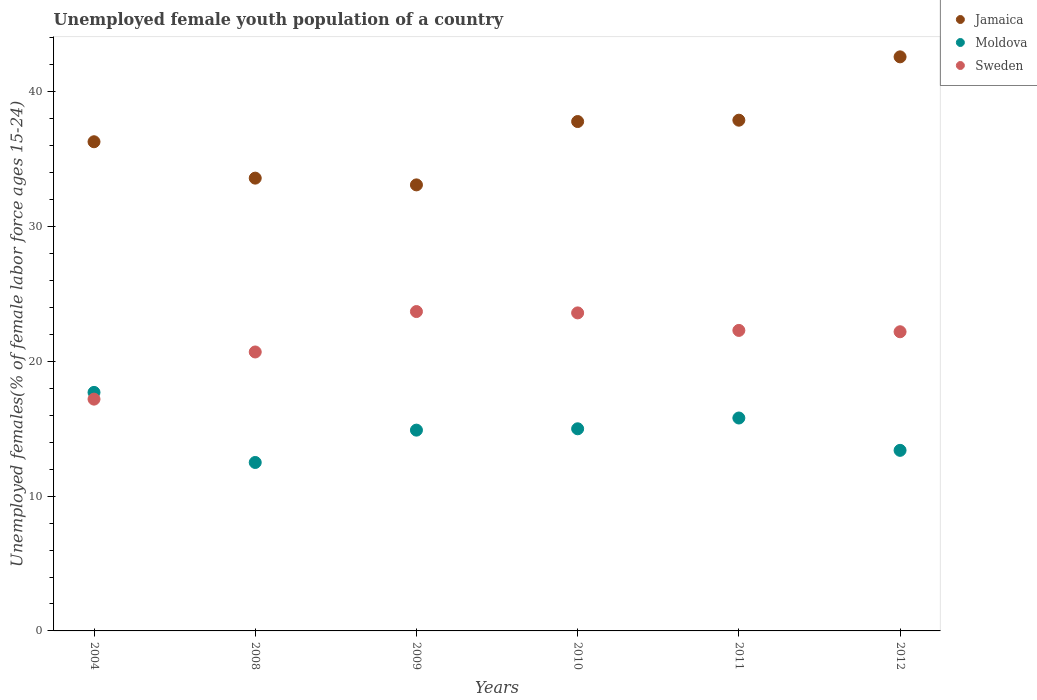How many different coloured dotlines are there?
Give a very brief answer. 3. What is the percentage of unemployed female youth population in Sweden in 2009?
Provide a short and direct response. 23.7. Across all years, what is the maximum percentage of unemployed female youth population in Jamaica?
Offer a very short reply. 42.6. In which year was the percentage of unemployed female youth population in Moldova minimum?
Provide a succinct answer. 2008. What is the total percentage of unemployed female youth population in Sweden in the graph?
Your answer should be compact. 129.7. What is the difference between the percentage of unemployed female youth population in Moldova in 2010 and the percentage of unemployed female youth population in Sweden in 2009?
Make the answer very short. -8.7. What is the average percentage of unemployed female youth population in Moldova per year?
Provide a succinct answer. 14.88. In the year 2010, what is the difference between the percentage of unemployed female youth population in Sweden and percentage of unemployed female youth population in Moldova?
Provide a short and direct response. 8.6. In how many years, is the percentage of unemployed female youth population in Jamaica greater than 20 %?
Make the answer very short. 6. What is the ratio of the percentage of unemployed female youth population in Jamaica in 2009 to that in 2010?
Make the answer very short. 0.88. Is the difference between the percentage of unemployed female youth population in Sweden in 2004 and 2008 greater than the difference between the percentage of unemployed female youth population in Moldova in 2004 and 2008?
Provide a succinct answer. No. What is the difference between the highest and the second highest percentage of unemployed female youth population in Moldova?
Provide a short and direct response. 1.9. What is the difference between the highest and the lowest percentage of unemployed female youth population in Moldova?
Offer a very short reply. 5.2. Is the sum of the percentage of unemployed female youth population in Moldova in 2010 and 2012 greater than the maximum percentage of unemployed female youth population in Sweden across all years?
Ensure brevity in your answer.  Yes. Does the percentage of unemployed female youth population in Moldova monotonically increase over the years?
Your response must be concise. No. Is the percentage of unemployed female youth population in Moldova strictly less than the percentage of unemployed female youth population in Sweden over the years?
Your answer should be compact. No. How many years are there in the graph?
Offer a terse response. 6. Does the graph contain any zero values?
Make the answer very short. No. Where does the legend appear in the graph?
Your response must be concise. Top right. What is the title of the graph?
Your response must be concise. Unemployed female youth population of a country. Does "Rwanda" appear as one of the legend labels in the graph?
Provide a succinct answer. No. What is the label or title of the X-axis?
Make the answer very short. Years. What is the label or title of the Y-axis?
Offer a terse response. Unemployed females(% of female labor force ages 15-24). What is the Unemployed females(% of female labor force ages 15-24) of Jamaica in 2004?
Offer a very short reply. 36.3. What is the Unemployed females(% of female labor force ages 15-24) of Moldova in 2004?
Offer a terse response. 17.7. What is the Unemployed females(% of female labor force ages 15-24) of Sweden in 2004?
Offer a terse response. 17.2. What is the Unemployed females(% of female labor force ages 15-24) in Jamaica in 2008?
Offer a terse response. 33.6. What is the Unemployed females(% of female labor force ages 15-24) of Sweden in 2008?
Your answer should be very brief. 20.7. What is the Unemployed females(% of female labor force ages 15-24) of Jamaica in 2009?
Your answer should be compact. 33.1. What is the Unemployed females(% of female labor force ages 15-24) in Moldova in 2009?
Your response must be concise. 14.9. What is the Unemployed females(% of female labor force ages 15-24) in Sweden in 2009?
Offer a terse response. 23.7. What is the Unemployed females(% of female labor force ages 15-24) of Jamaica in 2010?
Ensure brevity in your answer.  37.8. What is the Unemployed females(% of female labor force ages 15-24) in Sweden in 2010?
Keep it short and to the point. 23.6. What is the Unemployed females(% of female labor force ages 15-24) of Jamaica in 2011?
Keep it short and to the point. 37.9. What is the Unemployed females(% of female labor force ages 15-24) of Moldova in 2011?
Give a very brief answer. 15.8. What is the Unemployed females(% of female labor force ages 15-24) of Sweden in 2011?
Provide a succinct answer. 22.3. What is the Unemployed females(% of female labor force ages 15-24) in Jamaica in 2012?
Provide a succinct answer. 42.6. What is the Unemployed females(% of female labor force ages 15-24) of Moldova in 2012?
Make the answer very short. 13.4. What is the Unemployed females(% of female labor force ages 15-24) in Sweden in 2012?
Offer a very short reply. 22.2. Across all years, what is the maximum Unemployed females(% of female labor force ages 15-24) of Jamaica?
Provide a short and direct response. 42.6. Across all years, what is the maximum Unemployed females(% of female labor force ages 15-24) in Moldova?
Provide a short and direct response. 17.7. Across all years, what is the maximum Unemployed females(% of female labor force ages 15-24) in Sweden?
Your answer should be compact. 23.7. Across all years, what is the minimum Unemployed females(% of female labor force ages 15-24) in Jamaica?
Provide a short and direct response. 33.1. Across all years, what is the minimum Unemployed females(% of female labor force ages 15-24) in Sweden?
Offer a very short reply. 17.2. What is the total Unemployed females(% of female labor force ages 15-24) in Jamaica in the graph?
Your response must be concise. 221.3. What is the total Unemployed females(% of female labor force ages 15-24) in Moldova in the graph?
Offer a terse response. 89.3. What is the total Unemployed females(% of female labor force ages 15-24) of Sweden in the graph?
Provide a short and direct response. 129.7. What is the difference between the Unemployed females(% of female labor force ages 15-24) in Sweden in 2004 and that in 2008?
Keep it short and to the point. -3.5. What is the difference between the Unemployed females(% of female labor force ages 15-24) in Jamaica in 2004 and that in 2009?
Keep it short and to the point. 3.2. What is the difference between the Unemployed females(% of female labor force ages 15-24) in Sweden in 2004 and that in 2010?
Provide a short and direct response. -6.4. What is the difference between the Unemployed females(% of female labor force ages 15-24) in Moldova in 2004 and that in 2011?
Provide a short and direct response. 1.9. What is the difference between the Unemployed females(% of female labor force ages 15-24) of Moldova in 2004 and that in 2012?
Provide a short and direct response. 4.3. What is the difference between the Unemployed females(% of female labor force ages 15-24) in Sweden in 2004 and that in 2012?
Offer a very short reply. -5. What is the difference between the Unemployed females(% of female labor force ages 15-24) of Moldova in 2008 and that in 2010?
Your answer should be very brief. -2.5. What is the difference between the Unemployed females(% of female labor force ages 15-24) of Jamaica in 2008 and that in 2011?
Your answer should be very brief. -4.3. What is the difference between the Unemployed females(% of female labor force ages 15-24) in Moldova in 2009 and that in 2011?
Make the answer very short. -0.9. What is the difference between the Unemployed females(% of female labor force ages 15-24) of Sweden in 2009 and that in 2011?
Your answer should be compact. 1.4. What is the difference between the Unemployed females(% of female labor force ages 15-24) in Moldova in 2009 and that in 2012?
Give a very brief answer. 1.5. What is the difference between the Unemployed females(% of female labor force ages 15-24) in Moldova in 2010 and that in 2011?
Your answer should be compact. -0.8. What is the difference between the Unemployed females(% of female labor force ages 15-24) of Sweden in 2010 and that in 2011?
Provide a succinct answer. 1.3. What is the difference between the Unemployed females(% of female labor force ages 15-24) in Jamaica in 2010 and that in 2012?
Offer a very short reply. -4.8. What is the difference between the Unemployed females(% of female labor force ages 15-24) in Sweden in 2010 and that in 2012?
Keep it short and to the point. 1.4. What is the difference between the Unemployed females(% of female labor force ages 15-24) in Jamaica in 2004 and the Unemployed females(% of female labor force ages 15-24) in Moldova in 2008?
Ensure brevity in your answer.  23.8. What is the difference between the Unemployed females(% of female labor force ages 15-24) of Jamaica in 2004 and the Unemployed females(% of female labor force ages 15-24) of Sweden in 2008?
Your response must be concise. 15.6. What is the difference between the Unemployed females(% of female labor force ages 15-24) in Jamaica in 2004 and the Unemployed females(% of female labor force ages 15-24) in Moldova in 2009?
Your answer should be compact. 21.4. What is the difference between the Unemployed females(% of female labor force ages 15-24) of Jamaica in 2004 and the Unemployed females(% of female labor force ages 15-24) of Sweden in 2009?
Ensure brevity in your answer.  12.6. What is the difference between the Unemployed females(% of female labor force ages 15-24) of Jamaica in 2004 and the Unemployed females(% of female labor force ages 15-24) of Moldova in 2010?
Your response must be concise. 21.3. What is the difference between the Unemployed females(% of female labor force ages 15-24) in Jamaica in 2004 and the Unemployed females(% of female labor force ages 15-24) in Sweden in 2010?
Give a very brief answer. 12.7. What is the difference between the Unemployed females(% of female labor force ages 15-24) in Moldova in 2004 and the Unemployed females(% of female labor force ages 15-24) in Sweden in 2010?
Your answer should be compact. -5.9. What is the difference between the Unemployed females(% of female labor force ages 15-24) in Jamaica in 2004 and the Unemployed females(% of female labor force ages 15-24) in Moldova in 2011?
Give a very brief answer. 20.5. What is the difference between the Unemployed females(% of female labor force ages 15-24) of Jamaica in 2004 and the Unemployed females(% of female labor force ages 15-24) of Sweden in 2011?
Keep it short and to the point. 14. What is the difference between the Unemployed females(% of female labor force ages 15-24) in Moldova in 2004 and the Unemployed females(% of female labor force ages 15-24) in Sweden in 2011?
Make the answer very short. -4.6. What is the difference between the Unemployed females(% of female labor force ages 15-24) in Jamaica in 2004 and the Unemployed females(% of female labor force ages 15-24) in Moldova in 2012?
Give a very brief answer. 22.9. What is the difference between the Unemployed females(% of female labor force ages 15-24) in Jamaica in 2004 and the Unemployed females(% of female labor force ages 15-24) in Sweden in 2012?
Give a very brief answer. 14.1. What is the difference between the Unemployed females(% of female labor force ages 15-24) of Jamaica in 2008 and the Unemployed females(% of female labor force ages 15-24) of Sweden in 2009?
Make the answer very short. 9.9. What is the difference between the Unemployed females(% of female labor force ages 15-24) of Moldova in 2008 and the Unemployed females(% of female labor force ages 15-24) of Sweden in 2009?
Your answer should be very brief. -11.2. What is the difference between the Unemployed females(% of female labor force ages 15-24) in Jamaica in 2008 and the Unemployed females(% of female labor force ages 15-24) in Moldova in 2010?
Your response must be concise. 18.6. What is the difference between the Unemployed females(% of female labor force ages 15-24) in Jamaica in 2008 and the Unemployed females(% of female labor force ages 15-24) in Sweden in 2010?
Offer a very short reply. 10. What is the difference between the Unemployed females(% of female labor force ages 15-24) in Moldova in 2008 and the Unemployed females(% of female labor force ages 15-24) in Sweden in 2010?
Make the answer very short. -11.1. What is the difference between the Unemployed females(% of female labor force ages 15-24) in Moldova in 2008 and the Unemployed females(% of female labor force ages 15-24) in Sweden in 2011?
Keep it short and to the point. -9.8. What is the difference between the Unemployed females(% of female labor force ages 15-24) in Jamaica in 2008 and the Unemployed females(% of female labor force ages 15-24) in Moldova in 2012?
Your response must be concise. 20.2. What is the difference between the Unemployed females(% of female labor force ages 15-24) of Jamaica in 2009 and the Unemployed females(% of female labor force ages 15-24) of Moldova in 2010?
Keep it short and to the point. 18.1. What is the difference between the Unemployed females(% of female labor force ages 15-24) in Jamaica in 2009 and the Unemployed females(% of female labor force ages 15-24) in Sweden in 2011?
Provide a short and direct response. 10.8. What is the difference between the Unemployed females(% of female labor force ages 15-24) in Moldova in 2009 and the Unemployed females(% of female labor force ages 15-24) in Sweden in 2011?
Provide a succinct answer. -7.4. What is the difference between the Unemployed females(% of female labor force ages 15-24) in Moldova in 2009 and the Unemployed females(% of female labor force ages 15-24) in Sweden in 2012?
Offer a very short reply. -7.3. What is the difference between the Unemployed females(% of female labor force ages 15-24) of Jamaica in 2010 and the Unemployed females(% of female labor force ages 15-24) of Moldova in 2011?
Offer a terse response. 22. What is the difference between the Unemployed females(% of female labor force ages 15-24) of Jamaica in 2010 and the Unemployed females(% of female labor force ages 15-24) of Sweden in 2011?
Provide a short and direct response. 15.5. What is the difference between the Unemployed females(% of female labor force ages 15-24) in Jamaica in 2010 and the Unemployed females(% of female labor force ages 15-24) in Moldova in 2012?
Keep it short and to the point. 24.4. What is the difference between the Unemployed females(% of female labor force ages 15-24) of Jamaica in 2010 and the Unemployed females(% of female labor force ages 15-24) of Sweden in 2012?
Your answer should be compact. 15.6. What is the difference between the Unemployed females(% of female labor force ages 15-24) of Jamaica in 2011 and the Unemployed females(% of female labor force ages 15-24) of Moldova in 2012?
Offer a terse response. 24.5. What is the difference between the Unemployed females(% of female labor force ages 15-24) in Jamaica in 2011 and the Unemployed females(% of female labor force ages 15-24) in Sweden in 2012?
Provide a succinct answer. 15.7. What is the average Unemployed females(% of female labor force ages 15-24) of Jamaica per year?
Offer a very short reply. 36.88. What is the average Unemployed females(% of female labor force ages 15-24) in Moldova per year?
Make the answer very short. 14.88. What is the average Unemployed females(% of female labor force ages 15-24) of Sweden per year?
Ensure brevity in your answer.  21.62. In the year 2004, what is the difference between the Unemployed females(% of female labor force ages 15-24) in Jamaica and Unemployed females(% of female labor force ages 15-24) in Sweden?
Give a very brief answer. 19.1. In the year 2008, what is the difference between the Unemployed females(% of female labor force ages 15-24) in Jamaica and Unemployed females(% of female labor force ages 15-24) in Moldova?
Offer a very short reply. 21.1. In the year 2008, what is the difference between the Unemployed females(% of female labor force ages 15-24) in Jamaica and Unemployed females(% of female labor force ages 15-24) in Sweden?
Provide a short and direct response. 12.9. In the year 2008, what is the difference between the Unemployed females(% of female labor force ages 15-24) in Moldova and Unemployed females(% of female labor force ages 15-24) in Sweden?
Make the answer very short. -8.2. In the year 2009, what is the difference between the Unemployed females(% of female labor force ages 15-24) of Jamaica and Unemployed females(% of female labor force ages 15-24) of Moldova?
Your answer should be very brief. 18.2. In the year 2009, what is the difference between the Unemployed females(% of female labor force ages 15-24) in Jamaica and Unemployed females(% of female labor force ages 15-24) in Sweden?
Ensure brevity in your answer.  9.4. In the year 2009, what is the difference between the Unemployed females(% of female labor force ages 15-24) in Moldova and Unemployed females(% of female labor force ages 15-24) in Sweden?
Your answer should be compact. -8.8. In the year 2010, what is the difference between the Unemployed females(% of female labor force ages 15-24) in Jamaica and Unemployed females(% of female labor force ages 15-24) in Moldova?
Your answer should be compact. 22.8. In the year 2010, what is the difference between the Unemployed females(% of female labor force ages 15-24) in Moldova and Unemployed females(% of female labor force ages 15-24) in Sweden?
Your answer should be compact. -8.6. In the year 2011, what is the difference between the Unemployed females(% of female labor force ages 15-24) of Jamaica and Unemployed females(% of female labor force ages 15-24) of Moldova?
Ensure brevity in your answer.  22.1. In the year 2011, what is the difference between the Unemployed females(% of female labor force ages 15-24) of Moldova and Unemployed females(% of female labor force ages 15-24) of Sweden?
Ensure brevity in your answer.  -6.5. In the year 2012, what is the difference between the Unemployed females(% of female labor force ages 15-24) in Jamaica and Unemployed females(% of female labor force ages 15-24) in Moldova?
Make the answer very short. 29.2. In the year 2012, what is the difference between the Unemployed females(% of female labor force ages 15-24) of Jamaica and Unemployed females(% of female labor force ages 15-24) of Sweden?
Offer a terse response. 20.4. In the year 2012, what is the difference between the Unemployed females(% of female labor force ages 15-24) in Moldova and Unemployed females(% of female labor force ages 15-24) in Sweden?
Ensure brevity in your answer.  -8.8. What is the ratio of the Unemployed females(% of female labor force ages 15-24) of Jamaica in 2004 to that in 2008?
Provide a succinct answer. 1.08. What is the ratio of the Unemployed females(% of female labor force ages 15-24) of Moldova in 2004 to that in 2008?
Keep it short and to the point. 1.42. What is the ratio of the Unemployed females(% of female labor force ages 15-24) of Sweden in 2004 to that in 2008?
Provide a succinct answer. 0.83. What is the ratio of the Unemployed females(% of female labor force ages 15-24) of Jamaica in 2004 to that in 2009?
Offer a terse response. 1.1. What is the ratio of the Unemployed females(% of female labor force ages 15-24) of Moldova in 2004 to that in 2009?
Offer a very short reply. 1.19. What is the ratio of the Unemployed females(% of female labor force ages 15-24) in Sweden in 2004 to that in 2009?
Keep it short and to the point. 0.73. What is the ratio of the Unemployed females(% of female labor force ages 15-24) in Jamaica in 2004 to that in 2010?
Your answer should be very brief. 0.96. What is the ratio of the Unemployed females(% of female labor force ages 15-24) of Moldova in 2004 to that in 2010?
Your answer should be compact. 1.18. What is the ratio of the Unemployed females(% of female labor force ages 15-24) of Sweden in 2004 to that in 2010?
Offer a very short reply. 0.73. What is the ratio of the Unemployed females(% of female labor force ages 15-24) of Jamaica in 2004 to that in 2011?
Give a very brief answer. 0.96. What is the ratio of the Unemployed females(% of female labor force ages 15-24) of Moldova in 2004 to that in 2011?
Provide a short and direct response. 1.12. What is the ratio of the Unemployed females(% of female labor force ages 15-24) of Sweden in 2004 to that in 2011?
Provide a succinct answer. 0.77. What is the ratio of the Unemployed females(% of female labor force ages 15-24) in Jamaica in 2004 to that in 2012?
Your response must be concise. 0.85. What is the ratio of the Unemployed females(% of female labor force ages 15-24) of Moldova in 2004 to that in 2012?
Provide a short and direct response. 1.32. What is the ratio of the Unemployed females(% of female labor force ages 15-24) in Sweden in 2004 to that in 2012?
Provide a succinct answer. 0.77. What is the ratio of the Unemployed females(% of female labor force ages 15-24) in Jamaica in 2008 to that in 2009?
Keep it short and to the point. 1.02. What is the ratio of the Unemployed females(% of female labor force ages 15-24) of Moldova in 2008 to that in 2009?
Keep it short and to the point. 0.84. What is the ratio of the Unemployed females(% of female labor force ages 15-24) of Sweden in 2008 to that in 2009?
Provide a succinct answer. 0.87. What is the ratio of the Unemployed females(% of female labor force ages 15-24) in Jamaica in 2008 to that in 2010?
Your response must be concise. 0.89. What is the ratio of the Unemployed females(% of female labor force ages 15-24) of Sweden in 2008 to that in 2010?
Provide a short and direct response. 0.88. What is the ratio of the Unemployed females(% of female labor force ages 15-24) of Jamaica in 2008 to that in 2011?
Provide a short and direct response. 0.89. What is the ratio of the Unemployed females(% of female labor force ages 15-24) of Moldova in 2008 to that in 2011?
Keep it short and to the point. 0.79. What is the ratio of the Unemployed females(% of female labor force ages 15-24) in Sweden in 2008 to that in 2011?
Provide a short and direct response. 0.93. What is the ratio of the Unemployed females(% of female labor force ages 15-24) in Jamaica in 2008 to that in 2012?
Offer a terse response. 0.79. What is the ratio of the Unemployed females(% of female labor force ages 15-24) in Moldova in 2008 to that in 2012?
Offer a terse response. 0.93. What is the ratio of the Unemployed females(% of female labor force ages 15-24) of Sweden in 2008 to that in 2012?
Offer a terse response. 0.93. What is the ratio of the Unemployed females(% of female labor force ages 15-24) of Jamaica in 2009 to that in 2010?
Offer a terse response. 0.88. What is the ratio of the Unemployed females(% of female labor force ages 15-24) in Moldova in 2009 to that in 2010?
Your answer should be very brief. 0.99. What is the ratio of the Unemployed females(% of female labor force ages 15-24) of Sweden in 2009 to that in 2010?
Keep it short and to the point. 1. What is the ratio of the Unemployed females(% of female labor force ages 15-24) of Jamaica in 2009 to that in 2011?
Provide a succinct answer. 0.87. What is the ratio of the Unemployed females(% of female labor force ages 15-24) in Moldova in 2009 to that in 2011?
Your response must be concise. 0.94. What is the ratio of the Unemployed females(% of female labor force ages 15-24) in Sweden in 2009 to that in 2011?
Offer a terse response. 1.06. What is the ratio of the Unemployed females(% of female labor force ages 15-24) of Jamaica in 2009 to that in 2012?
Make the answer very short. 0.78. What is the ratio of the Unemployed females(% of female labor force ages 15-24) in Moldova in 2009 to that in 2012?
Your response must be concise. 1.11. What is the ratio of the Unemployed females(% of female labor force ages 15-24) in Sweden in 2009 to that in 2012?
Keep it short and to the point. 1.07. What is the ratio of the Unemployed females(% of female labor force ages 15-24) in Jamaica in 2010 to that in 2011?
Your response must be concise. 1. What is the ratio of the Unemployed females(% of female labor force ages 15-24) in Moldova in 2010 to that in 2011?
Make the answer very short. 0.95. What is the ratio of the Unemployed females(% of female labor force ages 15-24) in Sweden in 2010 to that in 2011?
Offer a very short reply. 1.06. What is the ratio of the Unemployed females(% of female labor force ages 15-24) of Jamaica in 2010 to that in 2012?
Your response must be concise. 0.89. What is the ratio of the Unemployed females(% of female labor force ages 15-24) in Moldova in 2010 to that in 2012?
Offer a very short reply. 1.12. What is the ratio of the Unemployed females(% of female labor force ages 15-24) of Sweden in 2010 to that in 2012?
Provide a short and direct response. 1.06. What is the ratio of the Unemployed females(% of female labor force ages 15-24) of Jamaica in 2011 to that in 2012?
Your response must be concise. 0.89. What is the ratio of the Unemployed females(% of female labor force ages 15-24) of Moldova in 2011 to that in 2012?
Ensure brevity in your answer.  1.18. 